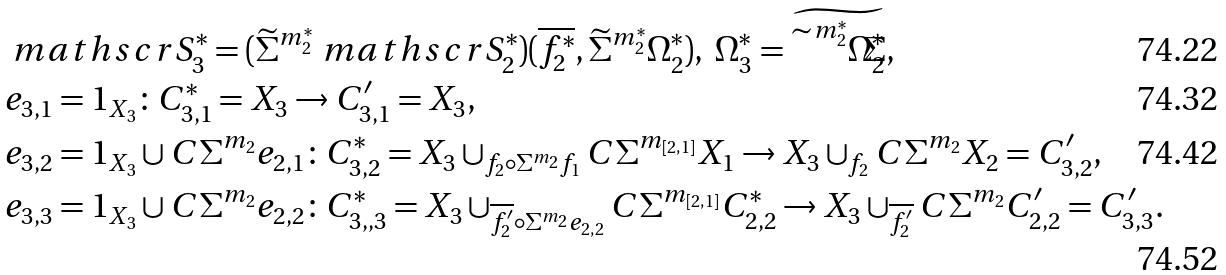Convert formula to latex. <formula><loc_0><loc_0><loc_500><loc_500>& \ m a t h s c r { S } ^ { * } _ { 3 } = ( \widetilde { \Sigma } ^ { m ^ { * } _ { 2 } } \ m a t h s c r { S } ^ { * } _ { 2 } ) ( \overline { f ^ { * } _ { 2 } } , \widetilde { \Sigma } ^ { m ^ { * } _ { 2 } } \Omega ^ { * } _ { 2 } ) , \ \Omega ^ { * } _ { 3 } = \widetilde { \widetilde { \Sigma } ^ { m ^ { * } _ { 2 } } \Omega ^ { * } _ { 2 } } , \\ & e _ { 3 , 1 } = 1 _ { X _ { 3 } } \colon C ^ { * } _ { 3 , 1 } = X _ { 3 } \to C ^ { \prime } _ { 3 , 1 } = X _ { 3 } , \\ & e _ { 3 , 2 } = 1 _ { X _ { 3 } } \cup C \Sigma ^ { m _ { 2 } } e _ { 2 , 1 } \colon C ^ { * } _ { 3 , 2 } = X _ { 3 } \cup _ { f _ { 2 } \circ \Sigma ^ { m _ { 2 } } f _ { 1 } } C \Sigma ^ { m _ { [ 2 , 1 ] } } X _ { 1 } \to X _ { 3 } \cup _ { f _ { 2 } } C \Sigma ^ { m _ { 2 } } X _ { 2 } = C ^ { \prime } _ { 3 , 2 } , \\ & e _ { 3 , 3 } = 1 _ { X _ { 3 } } \cup C \Sigma ^ { m _ { 2 } } e _ { 2 , 2 } \colon C ^ { * } _ { 3 , , 3 } = X _ { 3 } \cup _ { \overline { f ^ { \prime } _ { 2 } } \circ \Sigma ^ { m _ { 2 } } e _ { 2 , 2 } } C \Sigma ^ { m _ { [ 2 , 1 ] } } C ^ { * } _ { 2 , 2 } \to X _ { 3 } \cup _ { \overline { f ^ { \prime } _ { 2 } } } C \Sigma ^ { m _ { 2 } } C ^ { \prime } _ { 2 , 2 } = C ^ { \prime } _ { 3 , 3 } .</formula> 